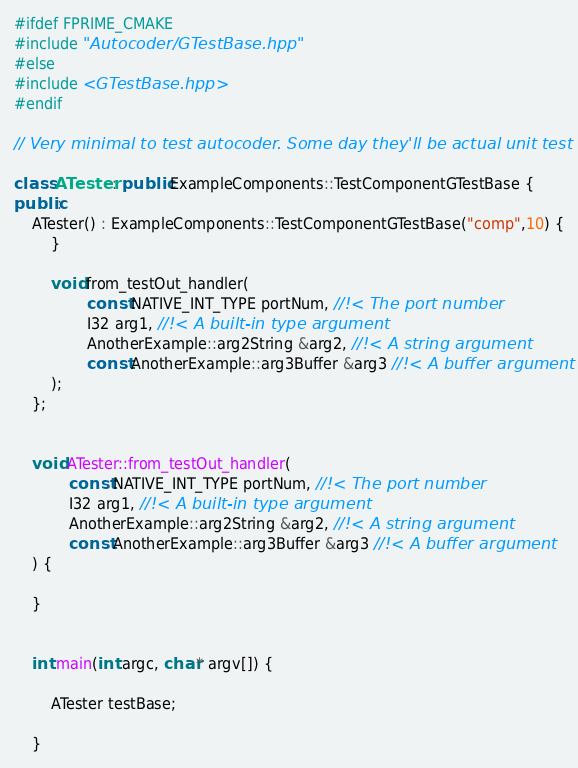Convert code to text. <code><loc_0><loc_0><loc_500><loc_500><_C++_>#ifdef FPRIME_CMAKE
#include "Autocoder/GTestBase.hpp"
#else
#include <GTestBase.hpp>
#endif

// Very minimal to test autocoder. Some day they'll be actual unit test code

class ATester : public ExampleComponents::TestComponentGTestBase {
public:
    ATester() : ExampleComponents::TestComponentGTestBase("comp",10) {
        }

        void from_testOut_handler(
                const NATIVE_INT_TYPE portNum, //!< The port number
                I32 arg1, //!< A built-in type argument
                AnotherExample::arg2String &arg2, //!< A string argument
                const AnotherExample::arg3Buffer &arg3 //!< A buffer argument
        );
    };


    void ATester::from_testOut_handler(
            const NATIVE_INT_TYPE portNum, //!< The port number
            I32 arg1, //!< A built-in type argument
            AnotherExample::arg2String &arg2, //!< A string argument
            const AnotherExample::arg3Buffer &arg3 //!< A buffer argument
    ) {

    }


    int main(int argc, char* argv[]) {

        ATester testBase;

    }
</code> 